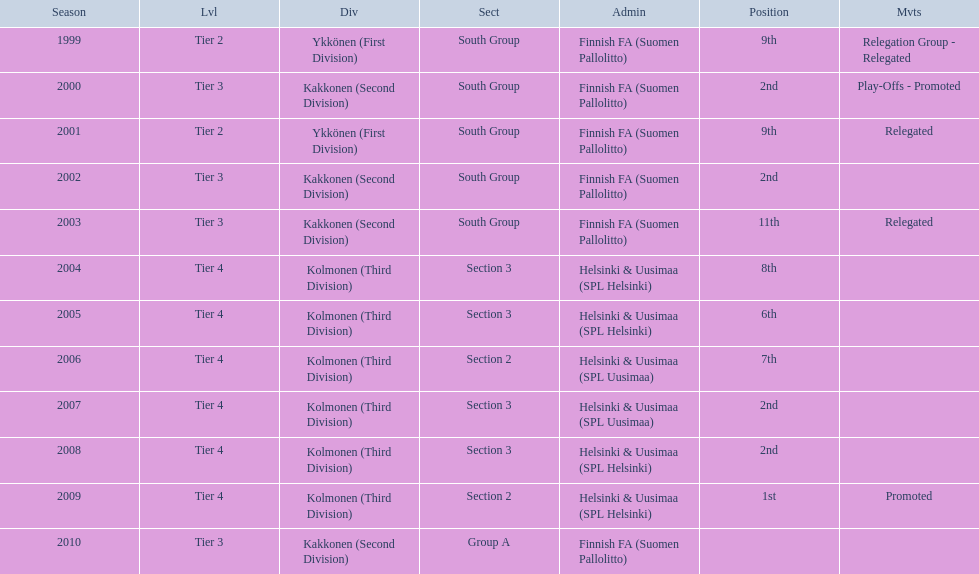Of the third division, how many were in section3? 4. 